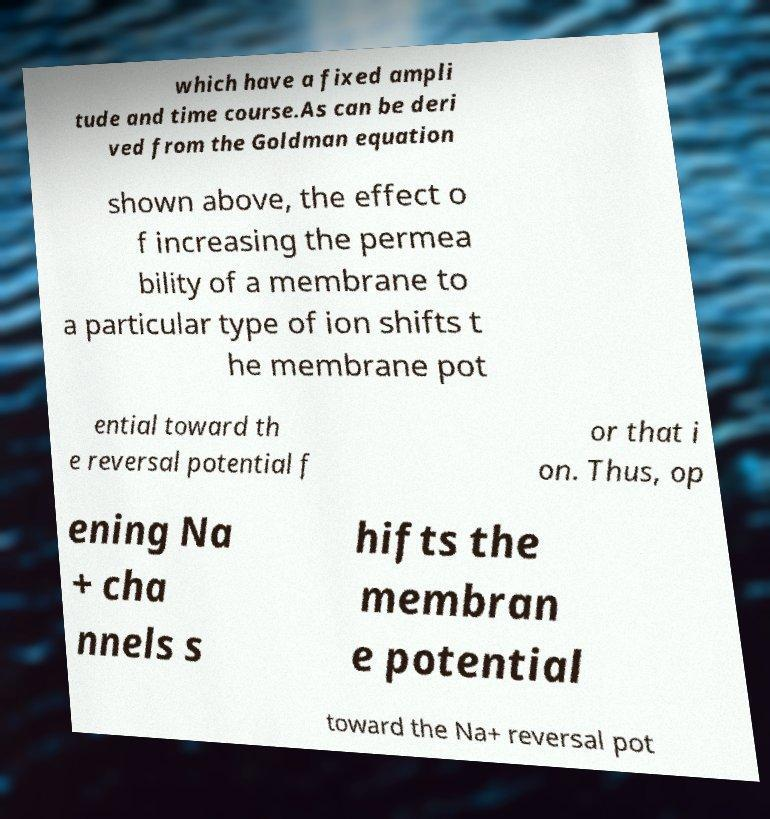Please identify and transcribe the text found in this image. which have a fixed ampli tude and time course.As can be deri ved from the Goldman equation shown above, the effect o f increasing the permea bility of a membrane to a particular type of ion shifts t he membrane pot ential toward th e reversal potential f or that i on. Thus, op ening Na + cha nnels s hifts the membran e potential toward the Na+ reversal pot 